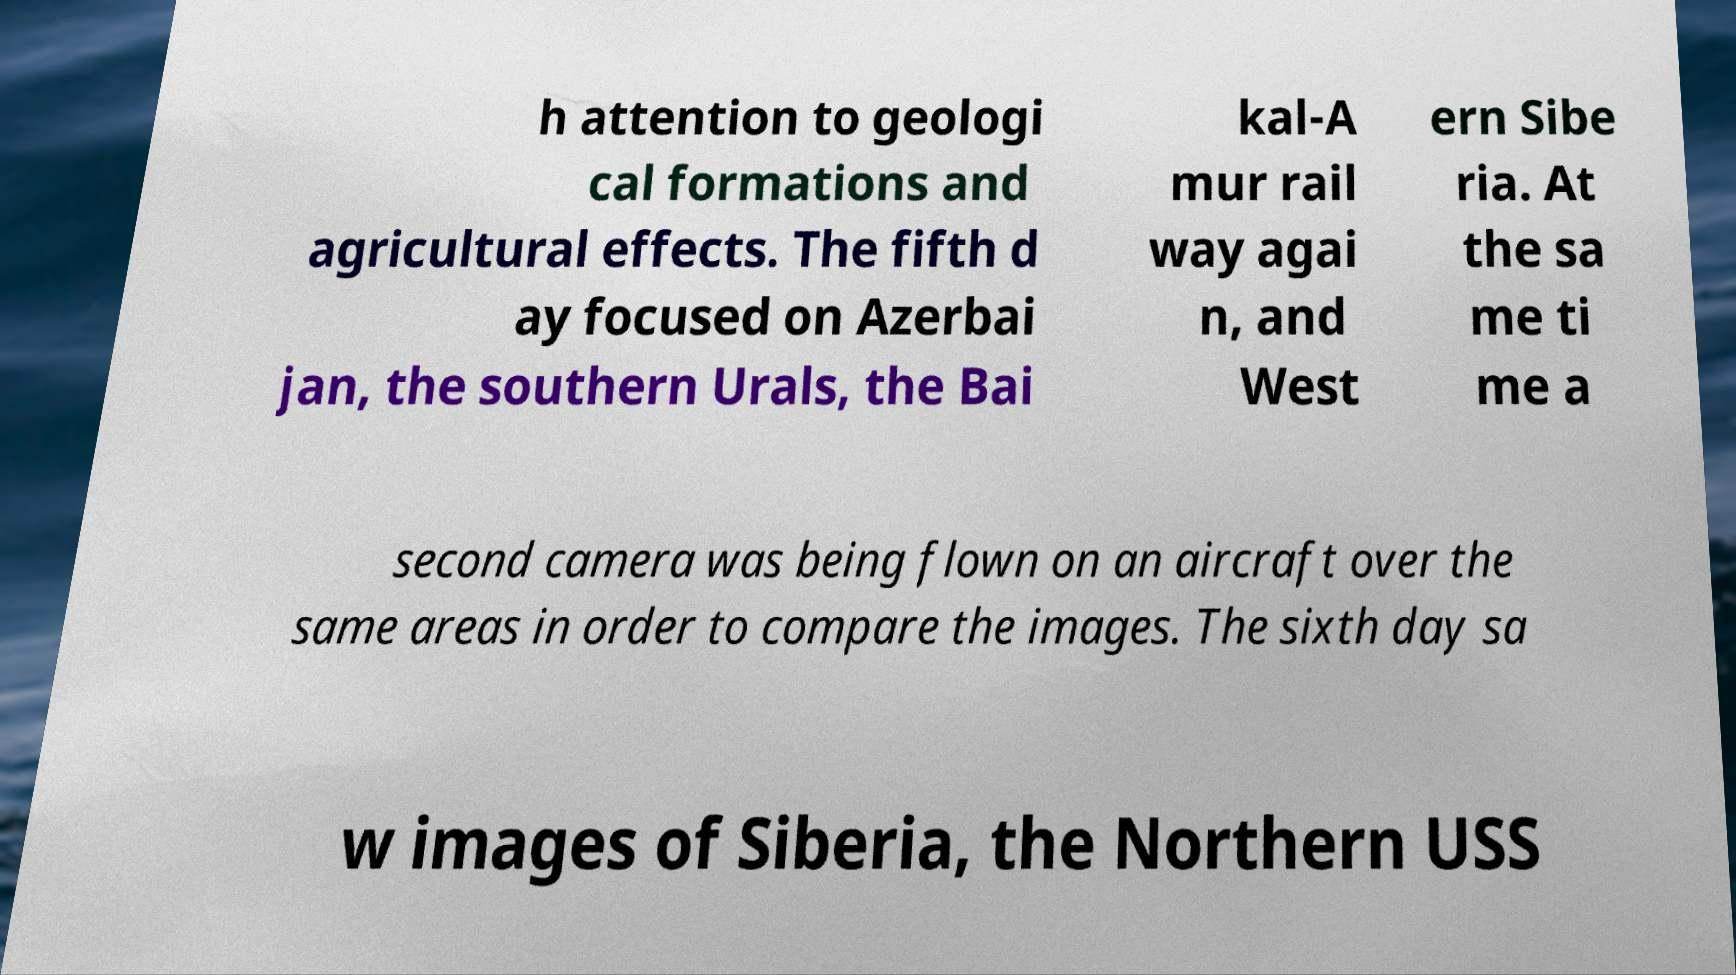Could you extract and type out the text from this image? h attention to geologi cal formations and agricultural effects. The fifth d ay focused on Azerbai jan, the southern Urals, the Bai kal-A mur rail way agai n, and West ern Sibe ria. At the sa me ti me a second camera was being flown on an aircraft over the same areas in order to compare the images. The sixth day sa w images of Siberia, the Northern USS 